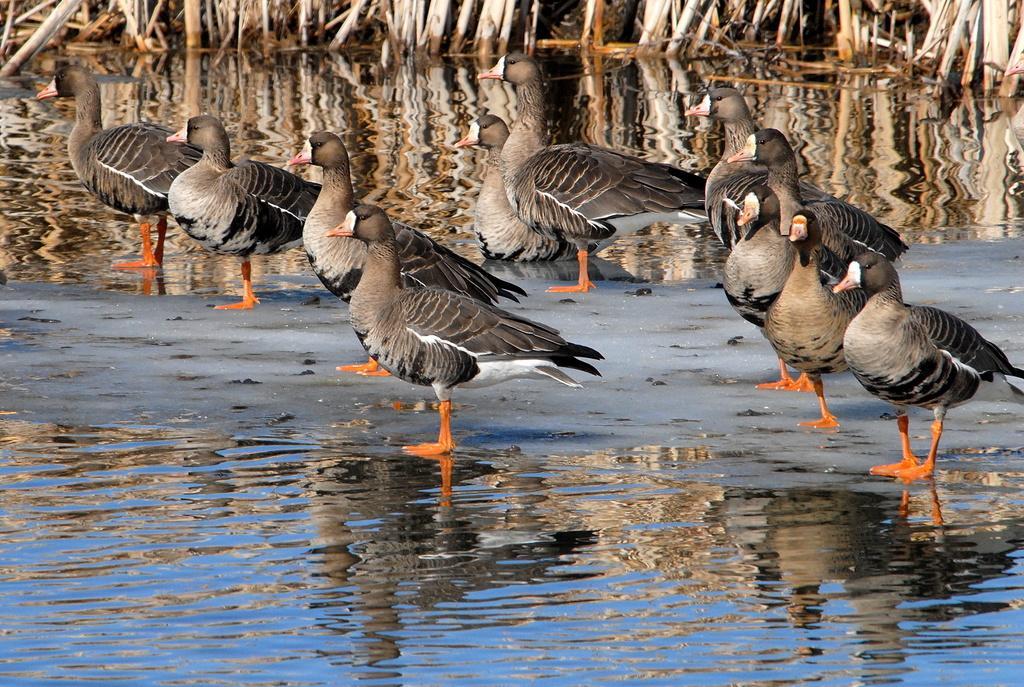Can you describe this image briefly? At the bottom there is water surface, behind that there is sand surface, on that there are duck, in the background there is water and there are sticks in that water. 